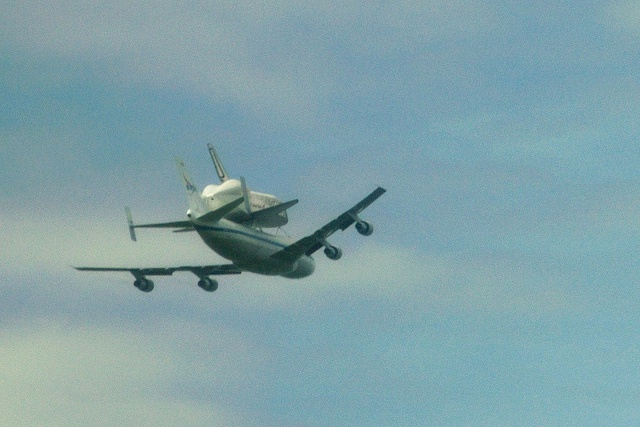Describe the objects in this image and their specific colors. I can see a airplane in gray, teal, black, and darkgray tones in this image. 